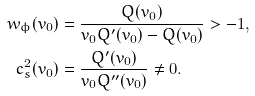<formula> <loc_0><loc_0><loc_500><loc_500>w _ { \phi } ( v _ { 0 } ) & = \frac { Q ( v _ { 0 } ) } { v _ { 0 } Q ^ { \prime } ( v _ { 0 } ) - Q ( v _ { 0 } ) } > - 1 , \\ c _ { s } ^ { 2 } ( v _ { 0 } ) & = \frac { Q ^ { \prime } ( v _ { 0 } ) } { v _ { 0 } Q ^ { \prime \prime } ( v _ { 0 } ) } \neq 0 .</formula> 